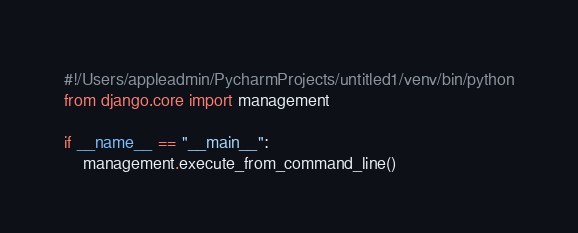Convert code to text. <code><loc_0><loc_0><loc_500><loc_500><_Python_>#!/Users/appleadmin/PycharmProjects/untitled1/venv/bin/python
from django.core import management

if __name__ == "__main__":
    management.execute_from_command_line()
</code> 